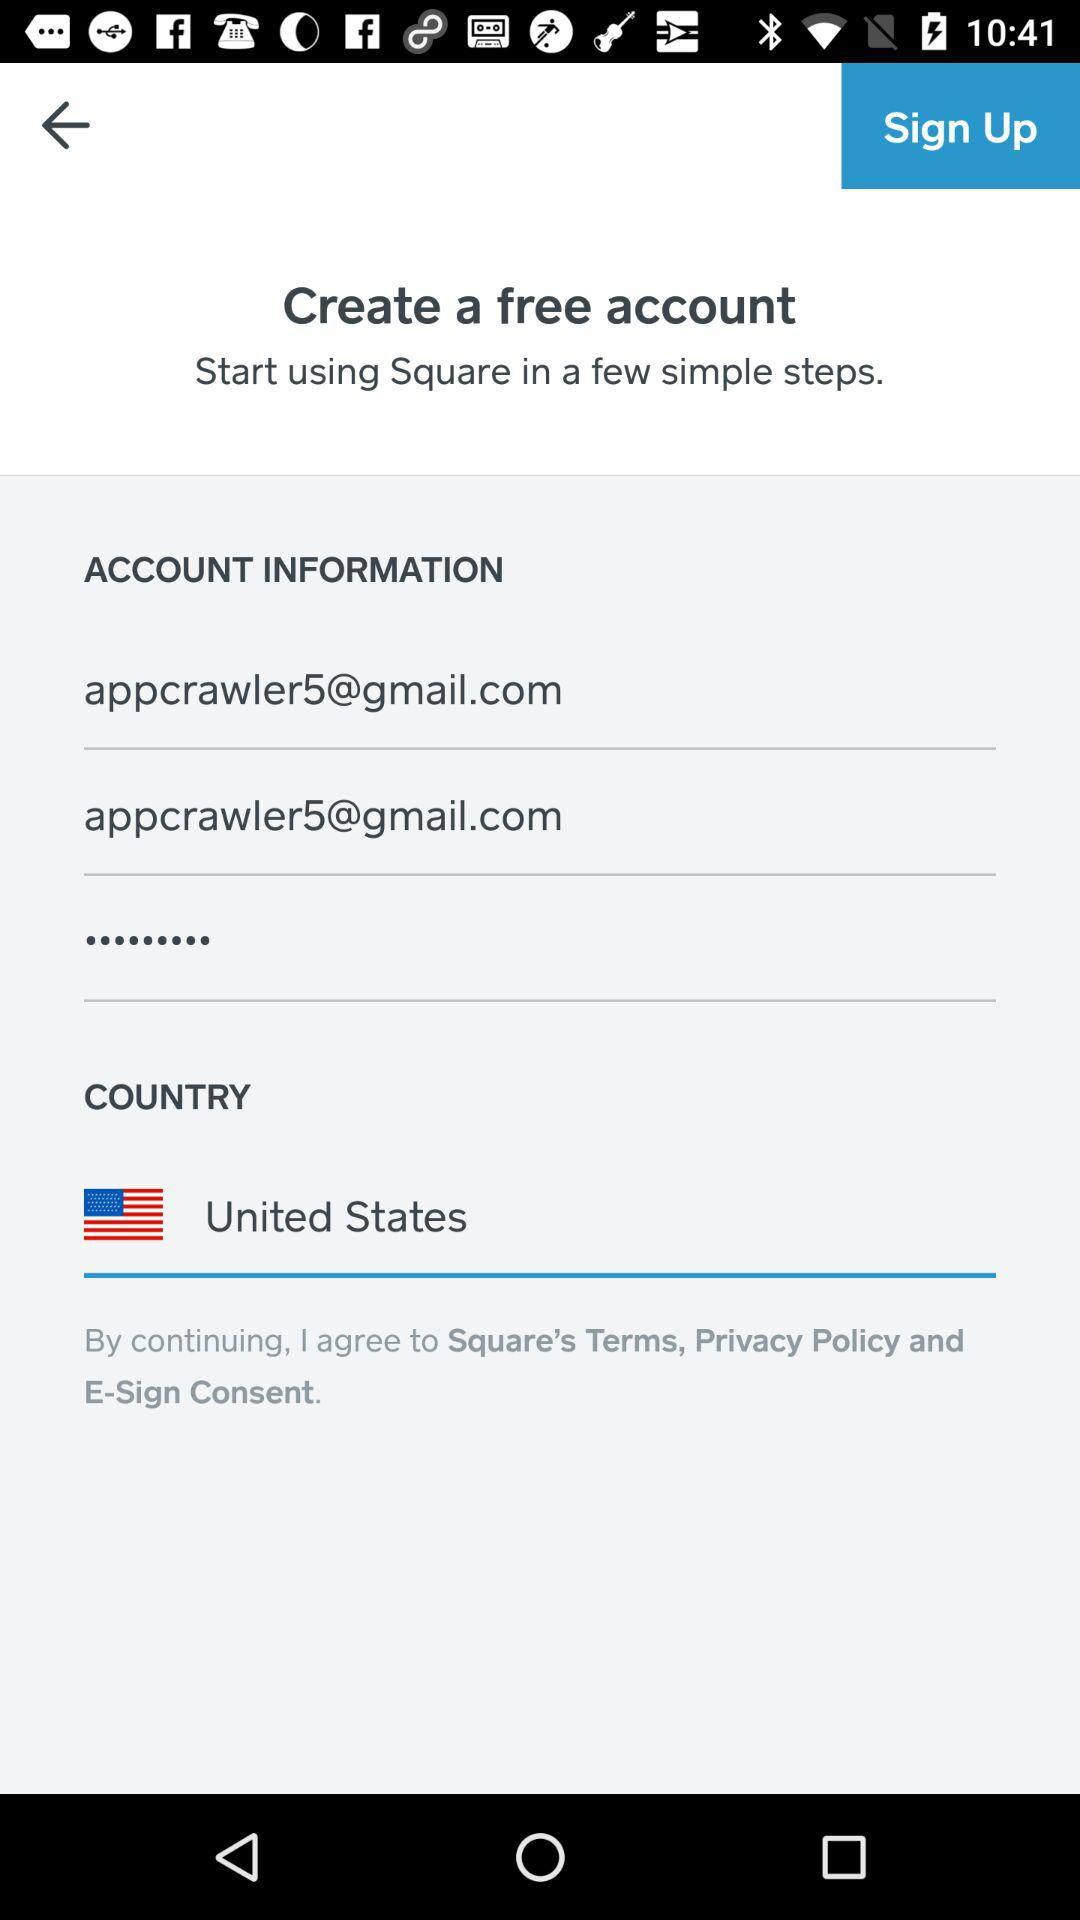How many text inputs have the value 'appcrawler5@gmail.com'?
Answer the question using a single word or phrase. 2 